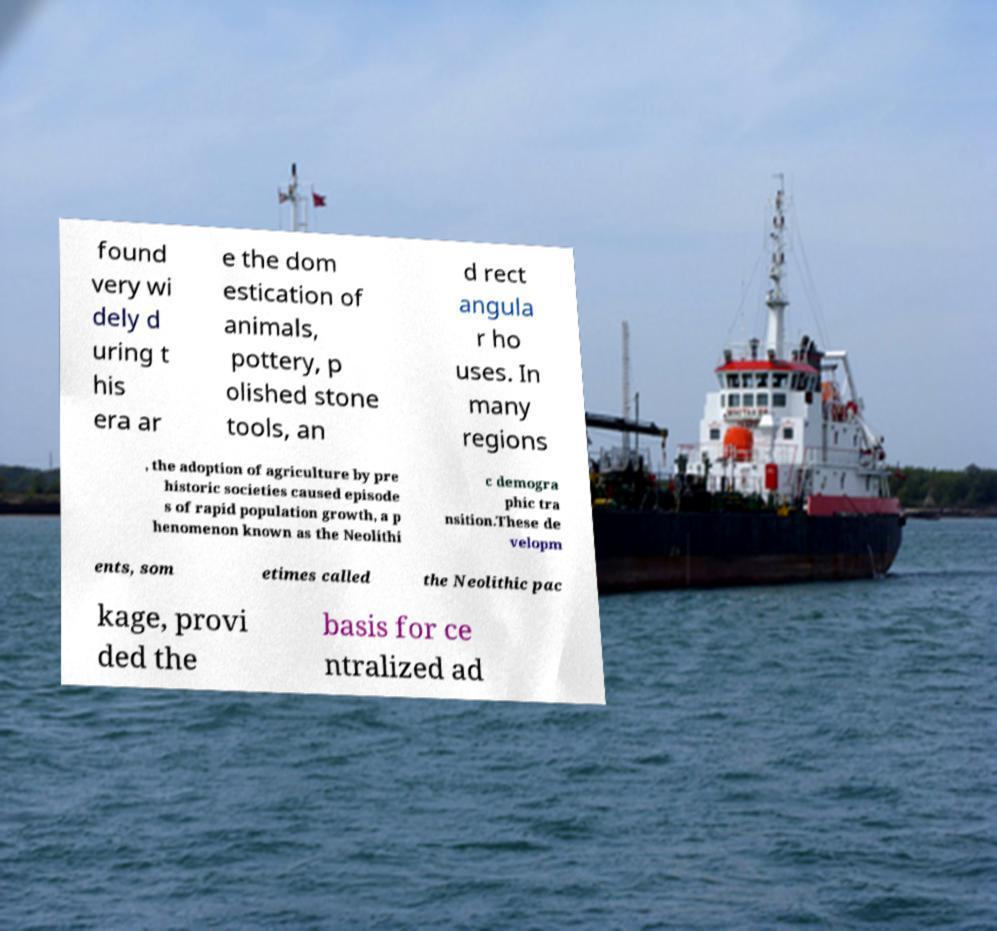There's text embedded in this image that I need extracted. Can you transcribe it verbatim? found very wi dely d uring t his era ar e the dom estication of animals, pottery, p olished stone tools, an d rect angula r ho uses. In many regions , the adoption of agriculture by pre historic societies caused episode s of rapid population growth, a p henomenon known as the Neolithi c demogra phic tra nsition.These de velopm ents, som etimes called the Neolithic pac kage, provi ded the basis for ce ntralized ad 